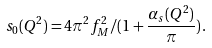Convert formula to latex. <formula><loc_0><loc_0><loc_500><loc_500>s _ { 0 } ( Q ^ { 2 } ) = 4 \pi ^ { 2 } f ^ { 2 } _ { M } / ( 1 + \frac { \alpha _ { s } ( Q ^ { 2 } ) } { \pi } ) \, .</formula> 